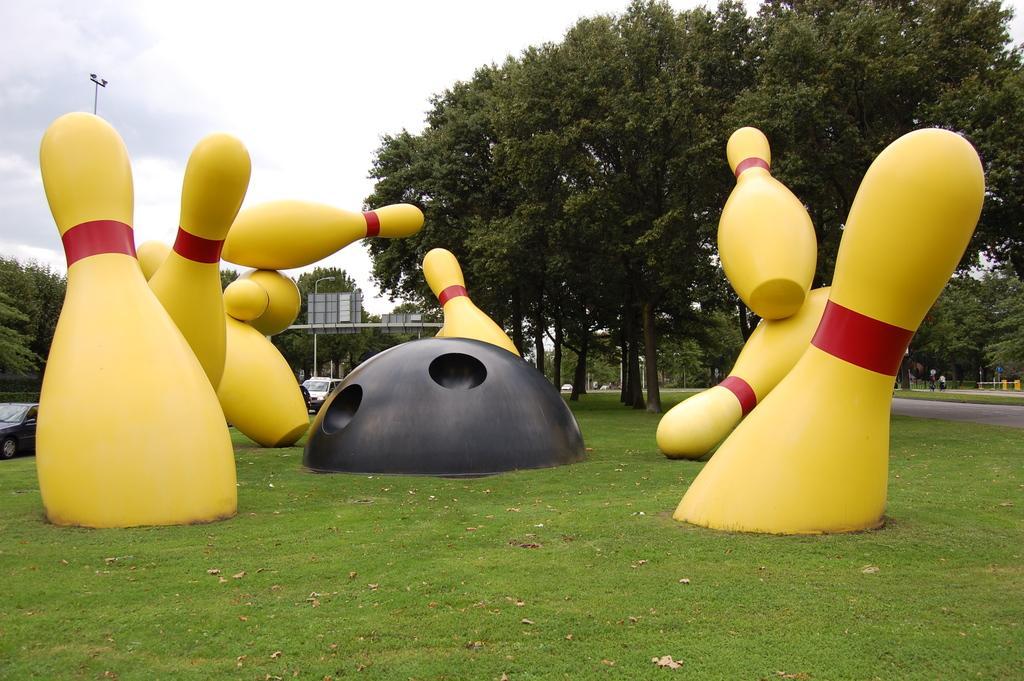Could you give a brief overview of what you see in this image? There are yellow color statues and a black color half sphere on which there are dots on the grass on the ground. In the background, there are vehicles on the road, there are trees and clouds in the sky. 